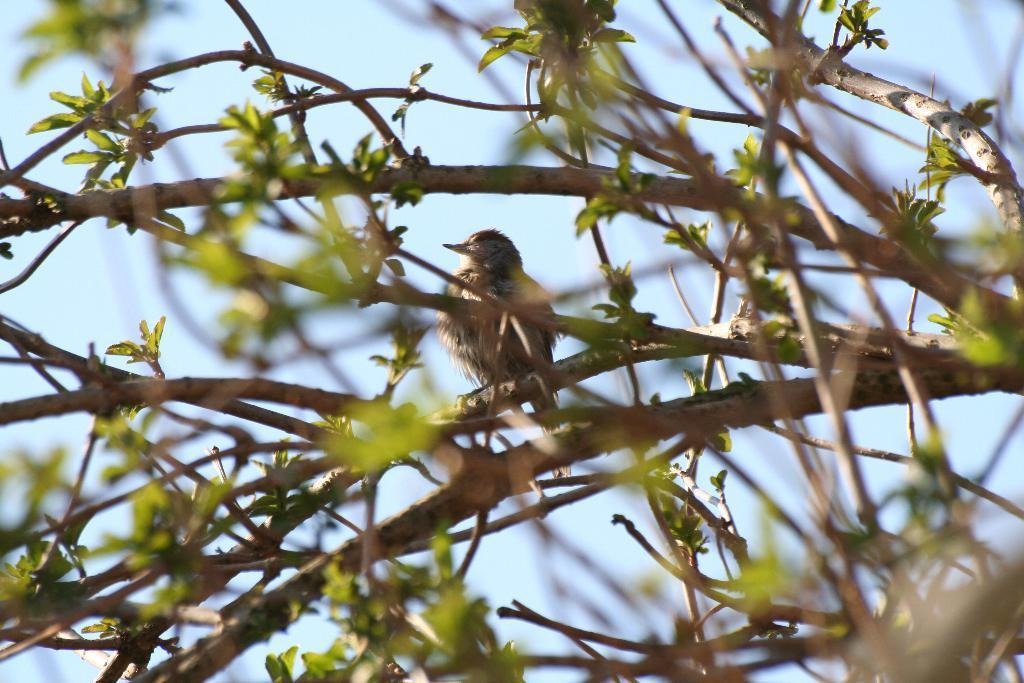In one or two sentences, can you explain what this image depicts? A bird is sitting on the green color tree, this is sky. 